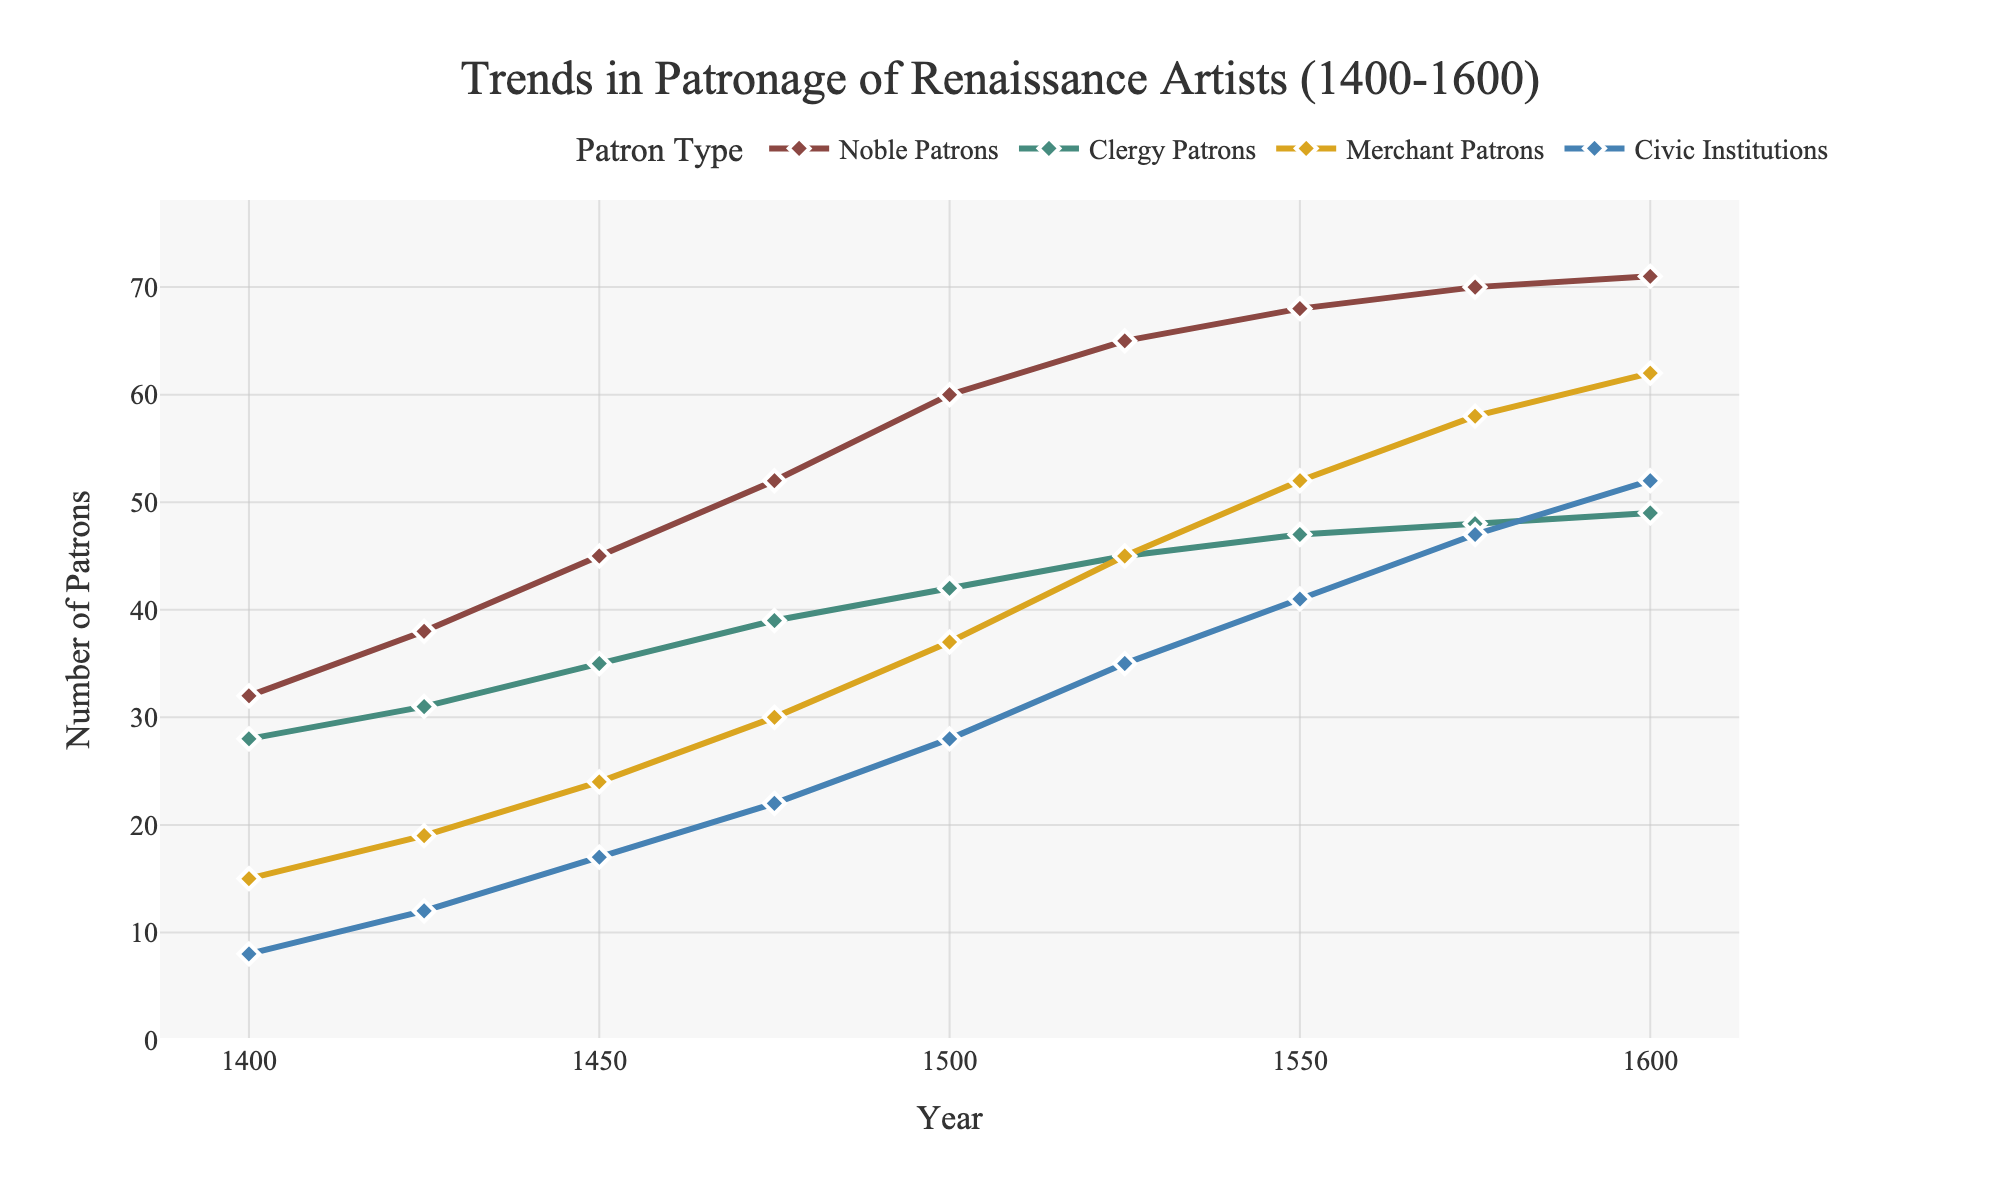What was the trend in the number of Noble Patrons from 1400 to 1600? To understand the trend, observe how the number of Noble Patrons changes over time on the graph. The number increases consistently from 32 in 1400 to 71 in 1600.
Answer: It increased consistently How does the number of Civic Institution patrons in 1600 compare to the number of Merchant Patrons in 1550? Locate the data points for 1600 and 1550 on the graph. In 1600, Civic Institution patrons were 52, while Merchant Patrons in 1550 were 52.
Answer: They are equal What is the approximate average number of Clergy Patrons across all recorded years? Sum the number of Clergy Patrons for each year and divide by the number of years: (28+31+35+39+42+45+47+48+49) / 9. This equals 404 / 9 = 44.89.
Answer: Approximately 45 Which social class saw the highest increase in patronage from 1400 to 1600? Compare the initial and final counts for each class. Noble Patrons increased by 71-32=39, Clergy Patrons by 49-28=21, Merchant Patrons by 62-15=47, and Civic Institutions by 52-8=44.
Answer: Merchant Patrons By how many did the number of Merchant Patrons increase from 1475 to 1525? Find the number of Merchant Patrons in 1475 (30) and in 1525 (45); then subtract 30 from 45.
Answer: By 15 What is the percentage increase in the number of Clergy Patrons from 1400 to 1600? Find the counts in 1400 (28) and 1600 (49). The increase is 49 - 28 = 21. The percentage increase is (21/28) * 100.
Answer: 75% During which 25-year period did Civic Institutions experience the highest growth in patronage? Calculate the difference for Civic Institutions over each 25-year interval: 1400-1425 (4), 1425-1450 (5), 1450-1475 (5), 1475-1500 (6), 1500-1525 (7), 1525-1550 (6), 1550-1575 (6), 1575-1600 (5).
Answer: 1500-1525 How many more Merchant Patrons were there in 1600 compared to Noble Patrons in 1475? Locate the number of Merchant Patrons in 1600 (62) and Noble Patrons in 1475 (52), then subtract 52 from 62.
Answer: 10 more What combined total of patrons was there for all classes in 1500? Add the numbers of patrons from each class in 1500: 60 (Noble Patrons) + 42 (Clergy Patrons) + 37 (Merchant Patrons) + 28 (Civic Institutions) = 167.
Answer: 167 Which social class saw the smallest change in patronage from 1400 to 1600? Calculate the change for each class: Noble Patrons (39), Clergy Patrons (21), Merchant Patrons (47), Civic Institutions (44). The smallest change is 21 for Clergy Patrons.
Answer: Clergy Patrons 